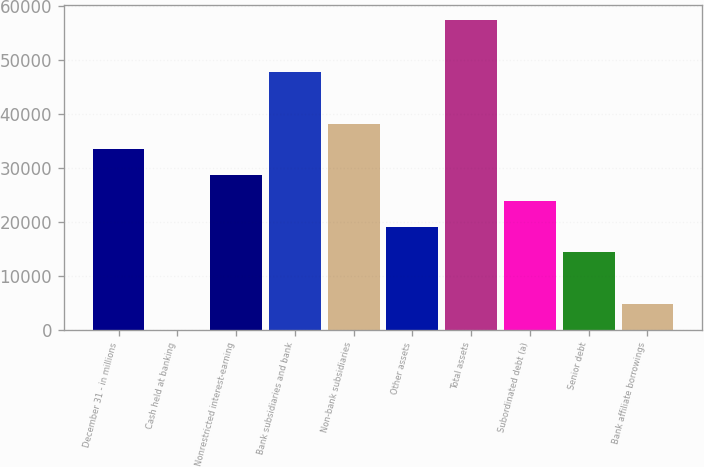Convert chart. <chart><loc_0><loc_0><loc_500><loc_500><bar_chart><fcel>December 31 - in millions<fcel>Cash held at banking<fcel>Nonrestricted interest-earning<fcel>Bank subsidiaries and bank<fcel>Non-bank subsidiaries<fcel>Other assets<fcel>Total assets<fcel>Subordinated debt (a)<fcel>Senior debt<fcel>Bank affiliate borrowings<nl><fcel>33481.3<fcel>1<fcel>28698.4<fcel>47830<fcel>38264.2<fcel>19132.6<fcel>57395.8<fcel>23915.5<fcel>14349.7<fcel>4783.9<nl></chart> 